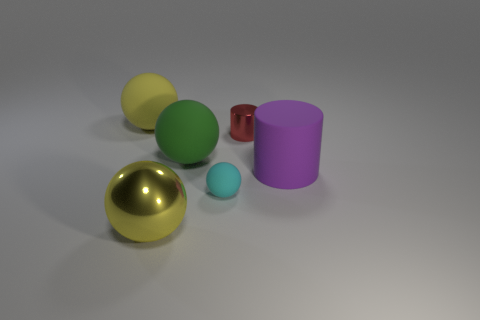Subtract all cyan matte balls. How many balls are left? 3 Add 3 yellow balls. How many objects exist? 9 Subtract all spheres. How many objects are left? 2 Subtract all brown cylinders. How many yellow balls are left? 2 Subtract 4 spheres. How many spheres are left? 0 Subtract all purple cylinders. How many cylinders are left? 1 Add 2 green metallic cylinders. How many green metallic cylinders exist? 2 Subtract 1 red cylinders. How many objects are left? 5 Subtract all purple balls. Subtract all purple cylinders. How many balls are left? 4 Subtract all cyan rubber things. Subtract all small shiny objects. How many objects are left? 4 